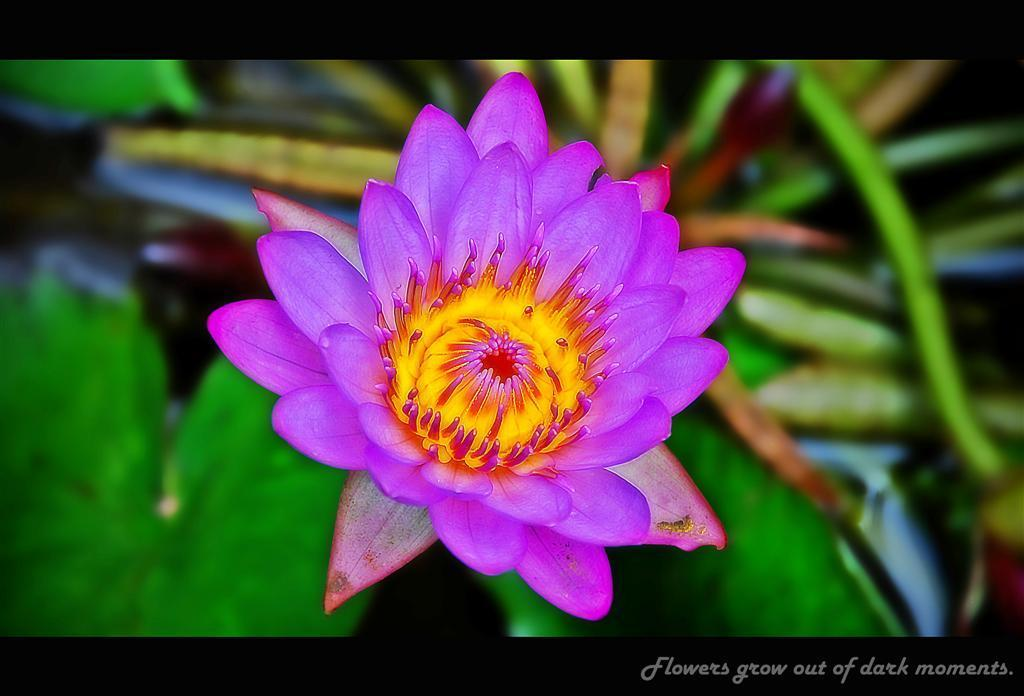What is the main subject of the image? There is a flower in the image. What color is the background of the image? The background of the image is green. Where is the text located in the image? The text is in the bottom right side of the image. What type of coil can be seen in the image? There is no coil present in the image; it features a flower and a green background. How does the dirt affect the flower in the image? There is no dirt present in the image; it features a flower and a green background. 